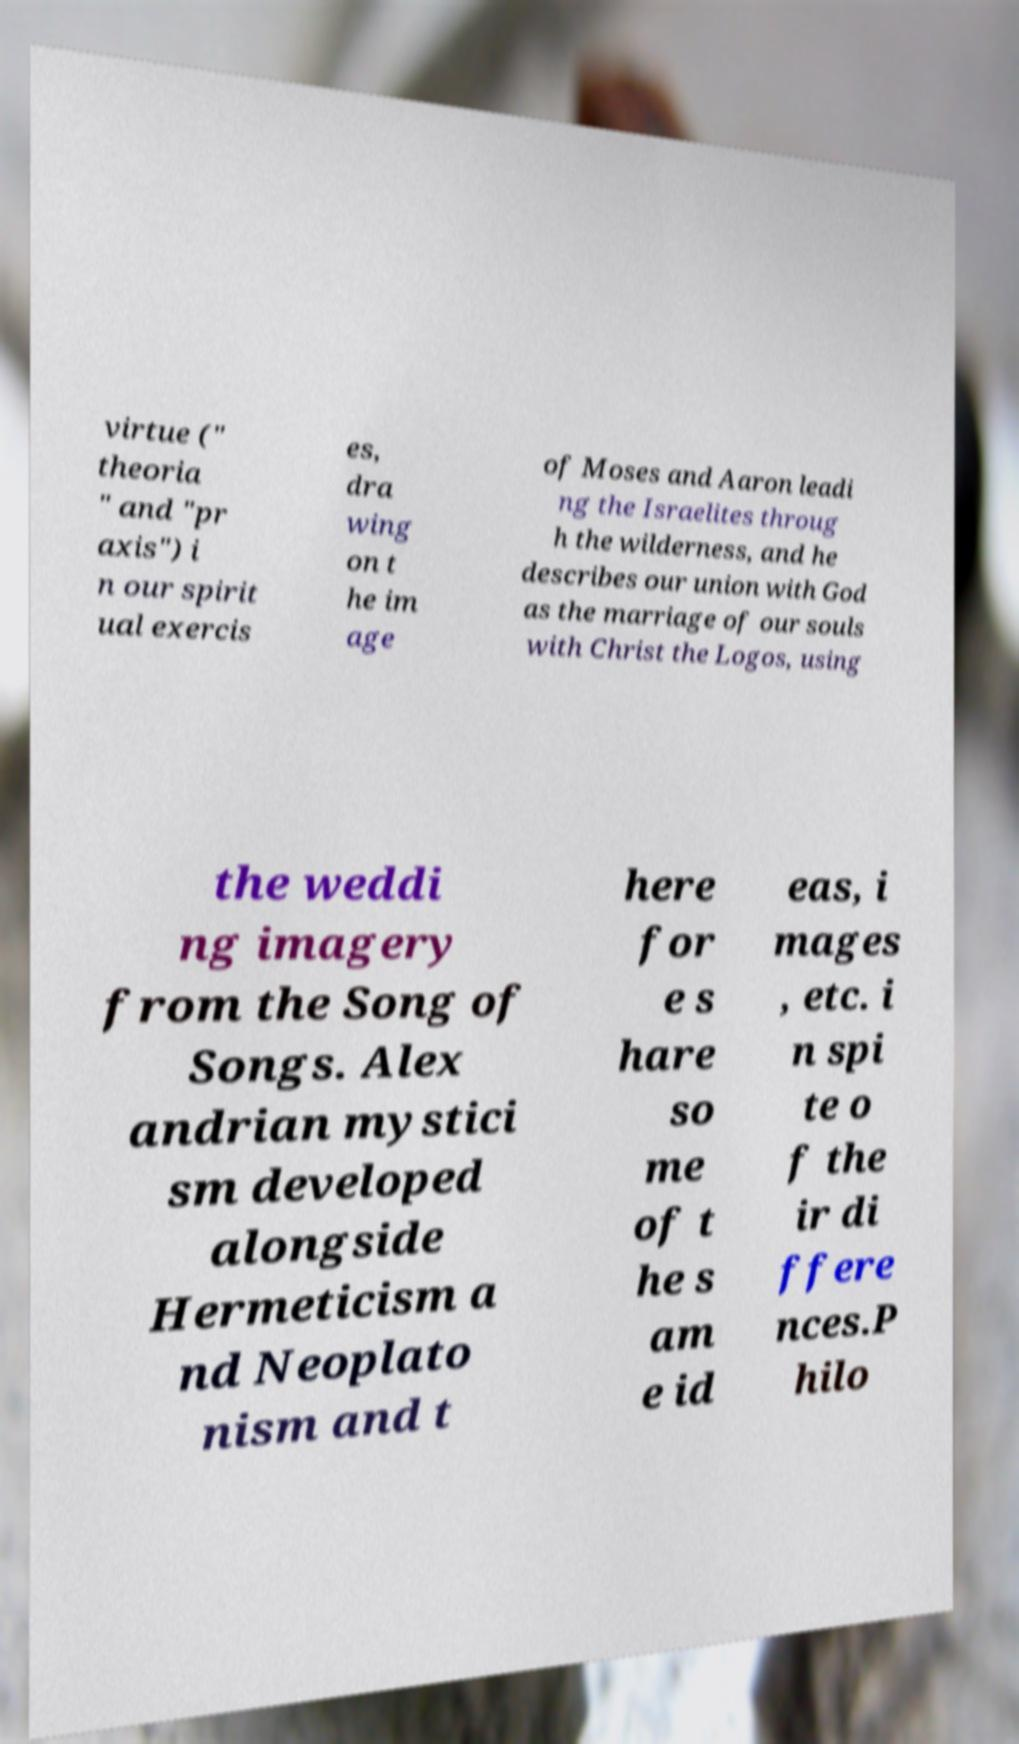Can you accurately transcribe the text from the provided image for me? virtue (" theoria " and "pr axis") i n our spirit ual exercis es, dra wing on t he im age of Moses and Aaron leadi ng the Israelites throug h the wilderness, and he describes our union with God as the marriage of our souls with Christ the Logos, using the weddi ng imagery from the Song of Songs. Alex andrian mystici sm developed alongside Hermeticism a nd Neoplato nism and t here for e s hare so me of t he s am e id eas, i mages , etc. i n spi te o f the ir di ffere nces.P hilo 